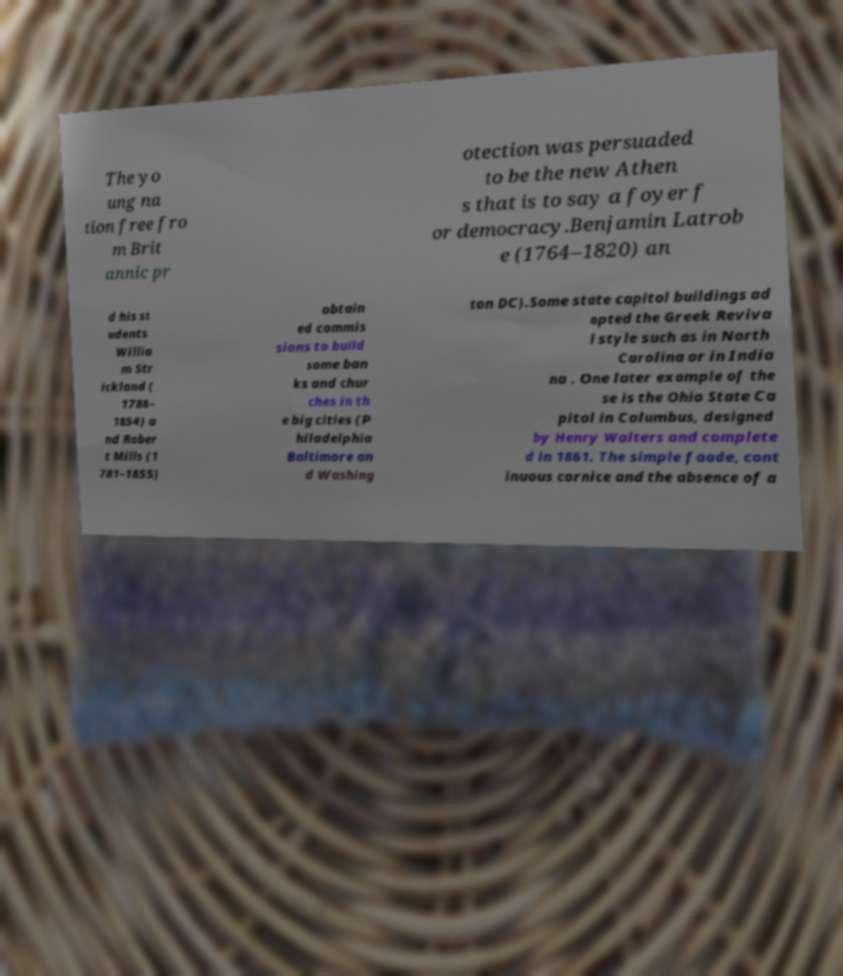Could you extract and type out the text from this image? The yo ung na tion free fro m Brit annic pr otection was persuaded to be the new Athen s that is to say a foyer f or democracy.Benjamin Latrob e (1764–1820) an d his st udents Willia m Str ickland ( 1788– 1854) a nd Rober t Mills (1 781–1855) obtain ed commis sions to build some ban ks and chur ches in th e big cities (P hiladelphia Baltimore an d Washing ton DC).Some state capitol buildings ad opted the Greek Reviva l style such as in North Carolina or in India na . One later example of the se is the Ohio State Ca pitol in Columbus, designed by Henry Walters and complete d in 1861. The simple faade, cont inuous cornice and the absence of a 